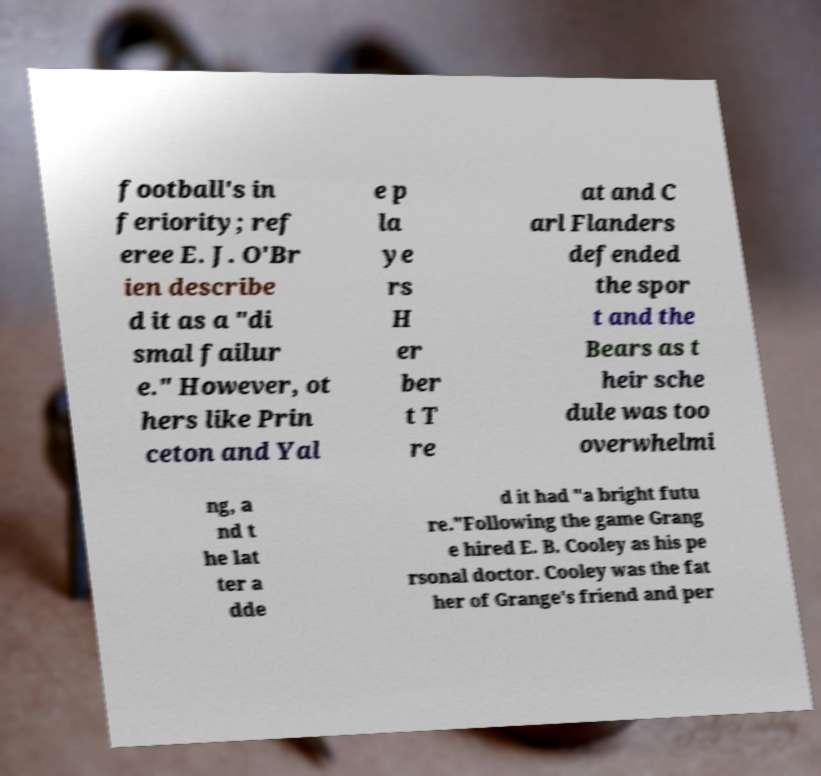For documentation purposes, I need the text within this image transcribed. Could you provide that? football's in feriority; ref eree E. J. O'Br ien describe d it as a "di smal failur e." However, ot hers like Prin ceton and Yal e p la ye rs H er ber t T re at and C arl Flanders defended the spor t and the Bears as t heir sche dule was too overwhelmi ng, a nd t he lat ter a dde d it had "a bright futu re."Following the game Grang e hired E. B. Cooley as his pe rsonal doctor. Cooley was the fat her of Grange's friend and per 